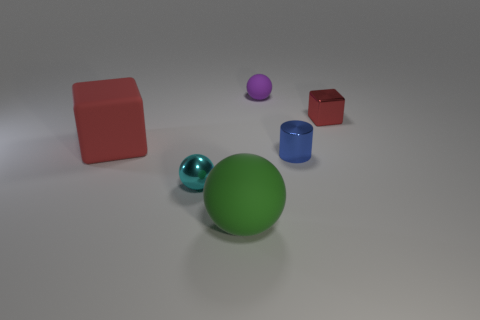The red matte thing is what size?
Offer a very short reply. Large. What number of blue metal cylinders are the same size as the red rubber object?
Your response must be concise. 0. What material is the tiny cyan object that is the same shape as the tiny purple thing?
Ensure brevity in your answer.  Metal. What is the shape of the small thing that is both in front of the large cube and on the right side of the tiny cyan object?
Provide a succinct answer. Cylinder. There is a small shiny object left of the purple rubber ball; what is its shape?
Provide a short and direct response. Sphere. How many things are both to the right of the large matte block and on the left side of the large green matte object?
Offer a very short reply. 1. There is a cyan ball; is it the same size as the red object on the right side of the small rubber thing?
Give a very brief answer. Yes. There is a cube on the right side of the tiny purple matte object that is right of the big matte thing left of the green sphere; how big is it?
Your answer should be compact. Small. There is a sphere left of the green matte sphere; what is its size?
Your response must be concise. Small. What shape is the small red thing that is made of the same material as the small blue thing?
Provide a succinct answer. Cube. 